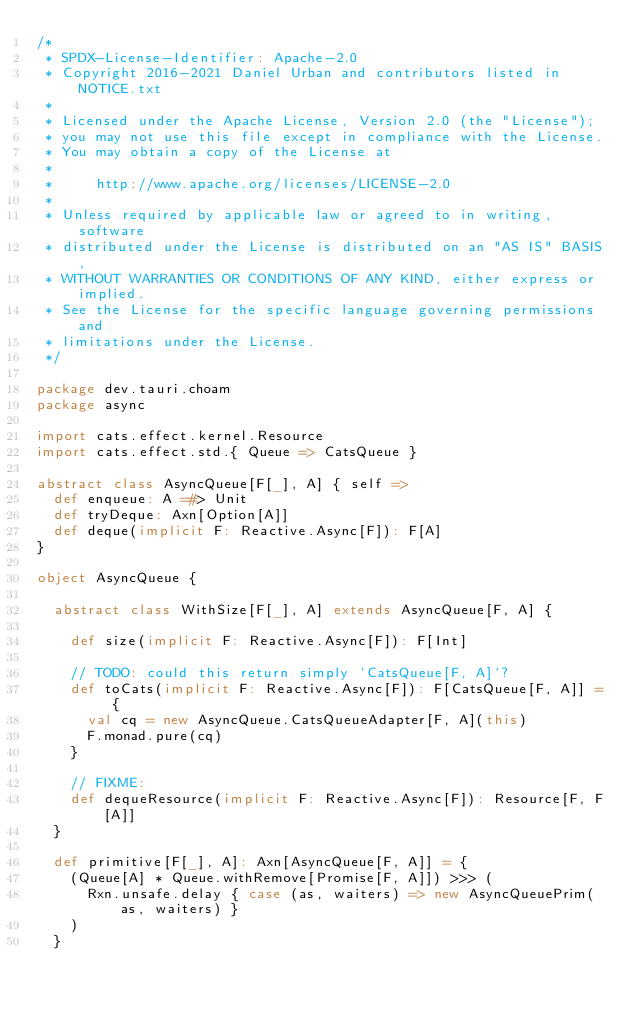Convert code to text. <code><loc_0><loc_0><loc_500><loc_500><_Scala_>/*
 * SPDX-License-Identifier: Apache-2.0
 * Copyright 2016-2021 Daniel Urban and contributors listed in NOTICE.txt
 *
 * Licensed under the Apache License, Version 2.0 (the "License");
 * you may not use this file except in compliance with the License.
 * You may obtain a copy of the License at
 *
 *     http://www.apache.org/licenses/LICENSE-2.0
 *
 * Unless required by applicable law or agreed to in writing, software
 * distributed under the License is distributed on an "AS IS" BASIS,
 * WITHOUT WARRANTIES OR CONDITIONS OF ANY KIND, either express or implied.
 * See the License for the specific language governing permissions and
 * limitations under the License.
 */

package dev.tauri.choam
package async

import cats.effect.kernel.Resource
import cats.effect.std.{ Queue => CatsQueue }

abstract class AsyncQueue[F[_], A] { self =>
  def enqueue: A =#> Unit
  def tryDeque: Axn[Option[A]]
  def deque(implicit F: Reactive.Async[F]): F[A]
}

object AsyncQueue {

  abstract class WithSize[F[_], A] extends AsyncQueue[F, A] {

    def size(implicit F: Reactive.Async[F]): F[Int]

    // TODO: could this return simply `CatsQueue[F, A]`?
    def toCats(implicit F: Reactive.Async[F]): F[CatsQueue[F, A]] = {
      val cq = new AsyncQueue.CatsQueueAdapter[F, A](this)
      F.monad.pure(cq)
    }

    // FIXME:
    def dequeResource(implicit F: Reactive.Async[F]): Resource[F, F[A]]
  }

  def primitive[F[_], A]: Axn[AsyncQueue[F, A]] = {
    (Queue[A] * Queue.withRemove[Promise[F, A]]) >>> (
      Rxn.unsafe.delay { case (as, waiters) => new AsyncQueuePrim(as, waiters) }
    )
  }
</code> 